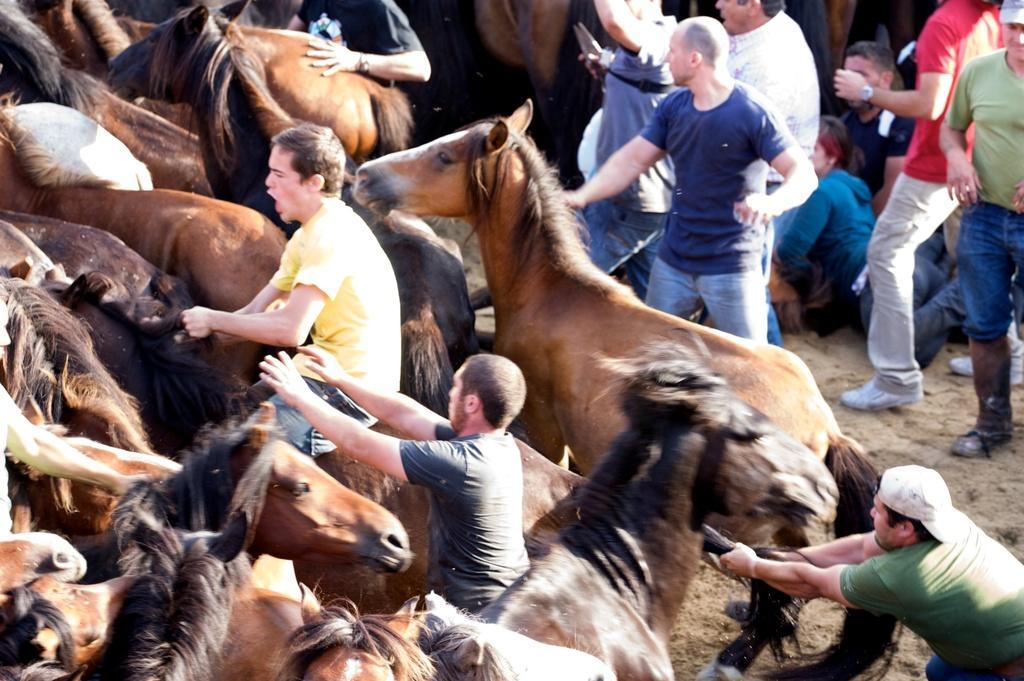Could you give a brief overview of what you see in this image? In this picture we can see group of people and horses, on the left side of the image we can see a man, he is seated on the horse. 